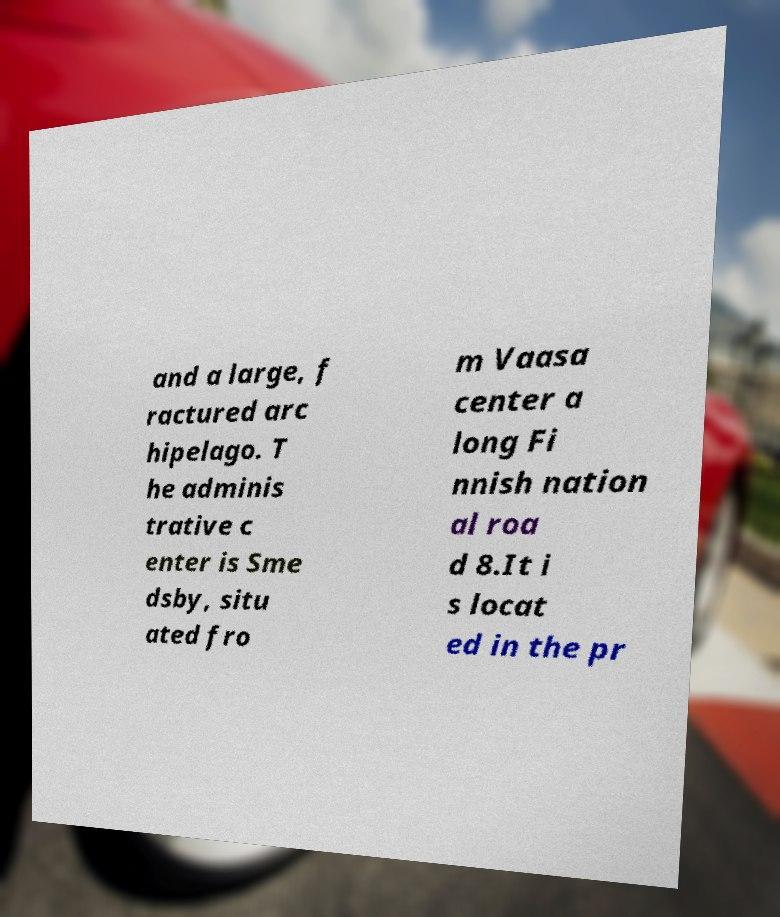Please identify and transcribe the text found in this image. and a large, f ractured arc hipelago. T he adminis trative c enter is Sme dsby, situ ated fro m Vaasa center a long Fi nnish nation al roa d 8.It i s locat ed in the pr 